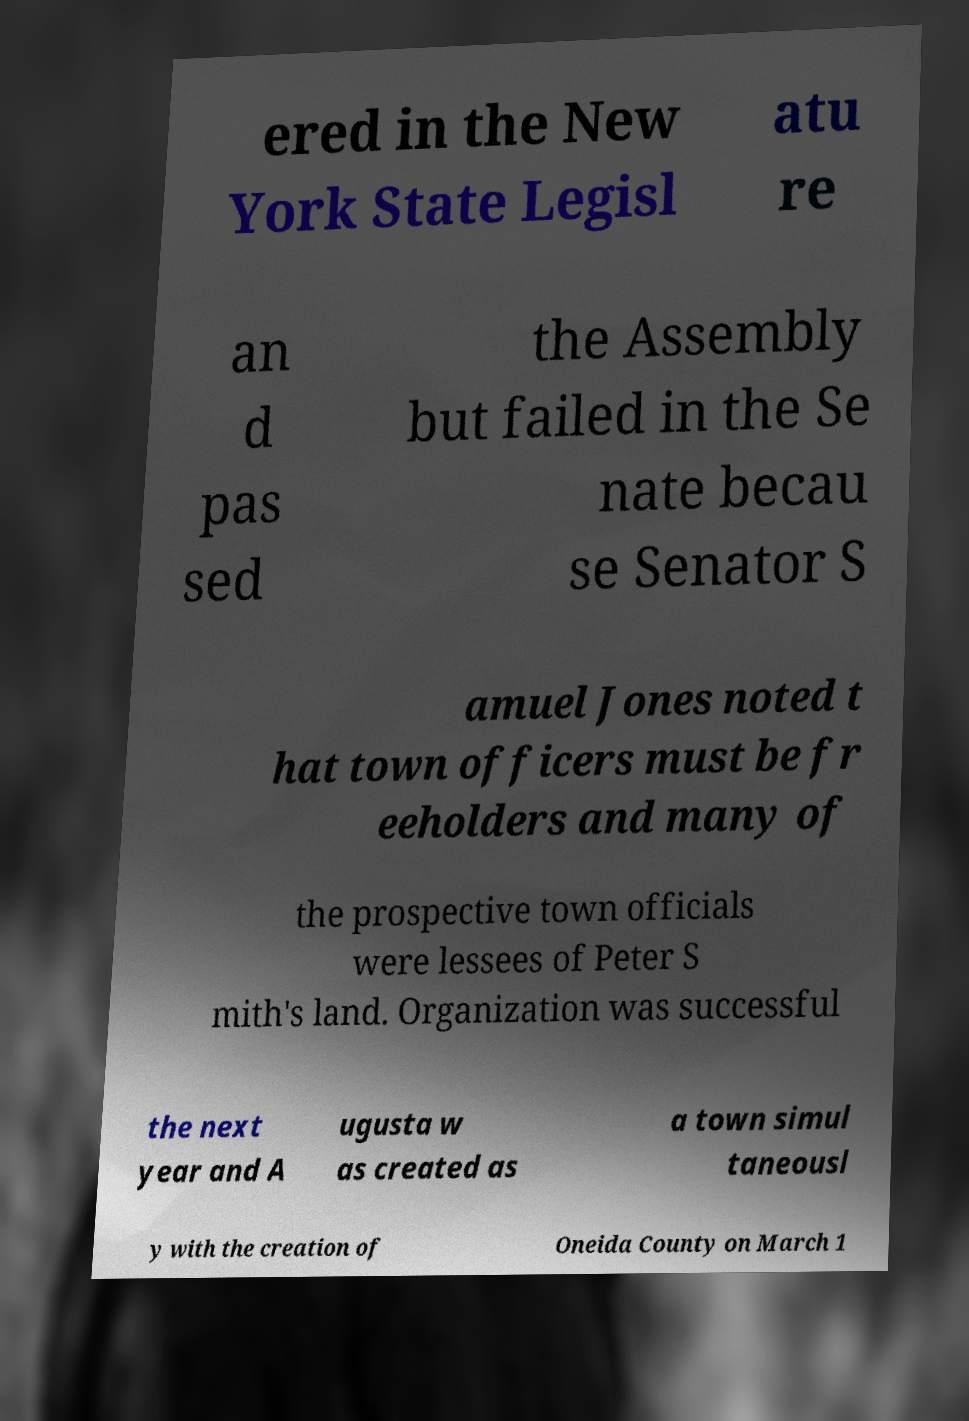Please identify and transcribe the text found in this image. ered in the New York State Legisl atu re an d pas sed the Assembly but failed in the Se nate becau se Senator S amuel Jones noted t hat town officers must be fr eeholders and many of the prospective town officials were lessees of Peter S mith's land. Organization was successful the next year and A ugusta w as created as a town simul taneousl y with the creation of Oneida County on March 1 